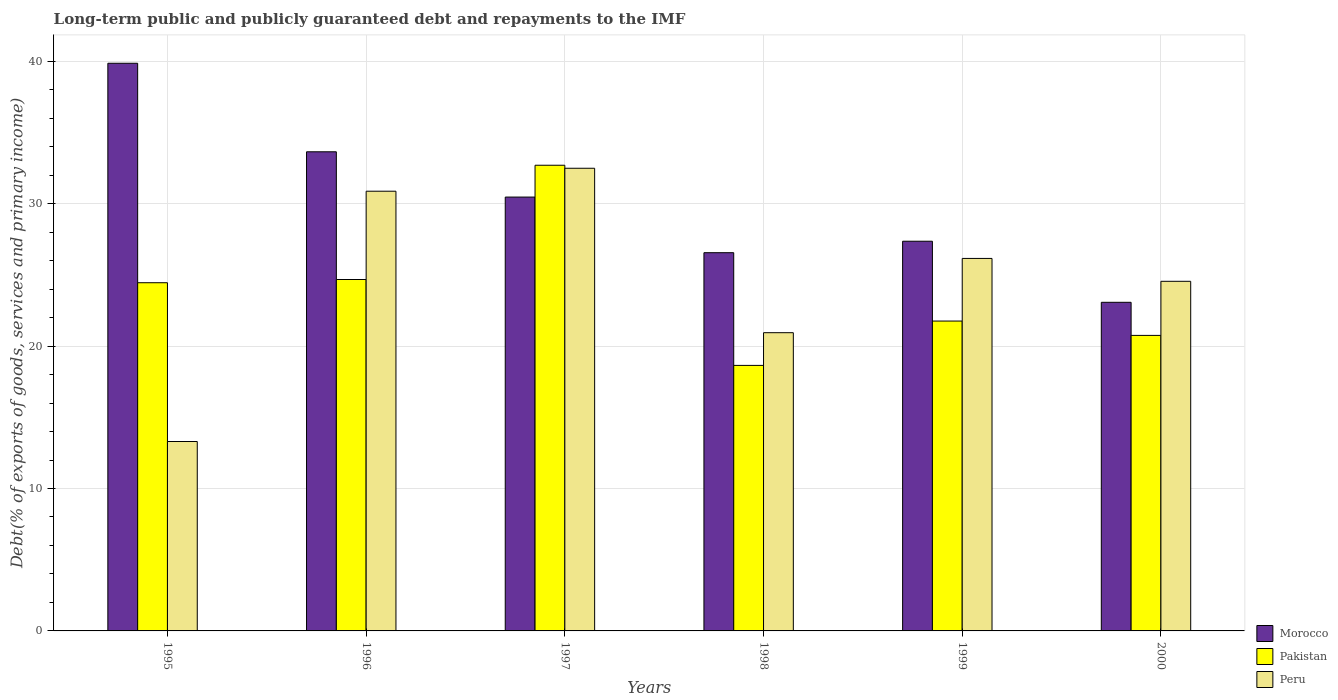How many different coloured bars are there?
Provide a succinct answer. 3. How many groups of bars are there?
Your response must be concise. 6. How many bars are there on the 5th tick from the left?
Make the answer very short. 3. What is the label of the 1st group of bars from the left?
Make the answer very short. 1995. What is the debt and repayments in Peru in 1999?
Your answer should be compact. 26.16. Across all years, what is the maximum debt and repayments in Peru?
Ensure brevity in your answer.  32.49. Across all years, what is the minimum debt and repayments in Morocco?
Make the answer very short. 23.08. What is the total debt and repayments in Peru in the graph?
Keep it short and to the point. 148.31. What is the difference between the debt and repayments in Morocco in 1996 and that in 1997?
Provide a short and direct response. 3.18. What is the difference between the debt and repayments in Peru in 2000 and the debt and repayments in Morocco in 1996?
Provide a short and direct response. -9.09. What is the average debt and repayments in Pakistan per year?
Provide a short and direct response. 23.83. In the year 1999, what is the difference between the debt and repayments in Morocco and debt and repayments in Peru?
Offer a very short reply. 1.21. In how many years, is the debt and repayments in Morocco greater than 36 %?
Give a very brief answer. 1. What is the ratio of the debt and repayments in Morocco in 1995 to that in 2000?
Offer a very short reply. 1.73. Is the difference between the debt and repayments in Morocco in 1995 and 1997 greater than the difference between the debt and repayments in Peru in 1995 and 1997?
Provide a short and direct response. Yes. What is the difference between the highest and the second highest debt and repayments in Morocco?
Provide a succinct answer. 6.22. What is the difference between the highest and the lowest debt and repayments in Peru?
Provide a succinct answer. 19.19. Is the sum of the debt and repayments in Peru in 1997 and 2000 greater than the maximum debt and repayments in Pakistan across all years?
Provide a succinct answer. Yes. What does the 1st bar from the left in 1997 represents?
Your answer should be compact. Morocco. What does the 1st bar from the right in 1996 represents?
Your response must be concise. Peru. Is it the case that in every year, the sum of the debt and repayments in Pakistan and debt and repayments in Morocco is greater than the debt and repayments in Peru?
Keep it short and to the point. Yes. Are all the bars in the graph horizontal?
Your answer should be very brief. No. How many years are there in the graph?
Your answer should be compact. 6. Does the graph contain any zero values?
Offer a very short reply. No. Does the graph contain grids?
Provide a succinct answer. Yes. How many legend labels are there?
Give a very brief answer. 3. How are the legend labels stacked?
Offer a very short reply. Vertical. What is the title of the graph?
Keep it short and to the point. Long-term public and publicly guaranteed debt and repayments to the IMF. What is the label or title of the X-axis?
Your answer should be very brief. Years. What is the label or title of the Y-axis?
Provide a succinct answer. Debt(% of exports of goods, services and primary income). What is the Debt(% of exports of goods, services and primary income) of Morocco in 1995?
Your response must be concise. 39.86. What is the Debt(% of exports of goods, services and primary income) of Pakistan in 1995?
Ensure brevity in your answer.  24.45. What is the Debt(% of exports of goods, services and primary income) in Peru in 1995?
Provide a succinct answer. 13.3. What is the Debt(% of exports of goods, services and primary income) of Morocco in 1996?
Ensure brevity in your answer.  33.64. What is the Debt(% of exports of goods, services and primary income) of Pakistan in 1996?
Offer a terse response. 24.68. What is the Debt(% of exports of goods, services and primary income) in Peru in 1996?
Your response must be concise. 30.88. What is the Debt(% of exports of goods, services and primary income) of Morocco in 1997?
Ensure brevity in your answer.  30.46. What is the Debt(% of exports of goods, services and primary income) of Pakistan in 1997?
Give a very brief answer. 32.7. What is the Debt(% of exports of goods, services and primary income) in Peru in 1997?
Provide a short and direct response. 32.49. What is the Debt(% of exports of goods, services and primary income) in Morocco in 1998?
Your response must be concise. 26.56. What is the Debt(% of exports of goods, services and primary income) in Pakistan in 1998?
Your answer should be compact. 18.64. What is the Debt(% of exports of goods, services and primary income) of Peru in 1998?
Provide a succinct answer. 20.94. What is the Debt(% of exports of goods, services and primary income) in Morocco in 1999?
Offer a terse response. 27.36. What is the Debt(% of exports of goods, services and primary income) of Pakistan in 1999?
Provide a short and direct response. 21.76. What is the Debt(% of exports of goods, services and primary income) in Peru in 1999?
Make the answer very short. 26.16. What is the Debt(% of exports of goods, services and primary income) in Morocco in 2000?
Your response must be concise. 23.08. What is the Debt(% of exports of goods, services and primary income) in Pakistan in 2000?
Keep it short and to the point. 20.75. What is the Debt(% of exports of goods, services and primary income) of Peru in 2000?
Your answer should be very brief. 24.55. Across all years, what is the maximum Debt(% of exports of goods, services and primary income) of Morocco?
Make the answer very short. 39.86. Across all years, what is the maximum Debt(% of exports of goods, services and primary income) of Pakistan?
Offer a very short reply. 32.7. Across all years, what is the maximum Debt(% of exports of goods, services and primary income) in Peru?
Your answer should be compact. 32.49. Across all years, what is the minimum Debt(% of exports of goods, services and primary income) in Morocco?
Your answer should be compact. 23.08. Across all years, what is the minimum Debt(% of exports of goods, services and primary income) in Pakistan?
Ensure brevity in your answer.  18.64. Across all years, what is the minimum Debt(% of exports of goods, services and primary income) in Peru?
Offer a very short reply. 13.3. What is the total Debt(% of exports of goods, services and primary income) of Morocco in the graph?
Your answer should be very brief. 180.97. What is the total Debt(% of exports of goods, services and primary income) in Pakistan in the graph?
Provide a short and direct response. 142.98. What is the total Debt(% of exports of goods, services and primary income) of Peru in the graph?
Your answer should be compact. 148.31. What is the difference between the Debt(% of exports of goods, services and primary income) in Morocco in 1995 and that in 1996?
Make the answer very short. 6.22. What is the difference between the Debt(% of exports of goods, services and primary income) in Pakistan in 1995 and that in 1996?
Your answer should be compact. -0.23. What is the difference between the Debt(% of exports of goods, services and primary income) in Peru in 1995 and that in 1996?
Offer a very short reply. -17.58. What is the difference between the Debt(% of exports of goods, services and primary income) in Morocco in 1995 and that in 1997?
Your response must be concise. 9.4. What is the difference between the Debt(% of exports of goods, services and primary income) in Pakistan in 1995 and that in 1997?
Provide a short and direct response. -8.25. What is the difference between the Debt(% of exports of goods, services and primary income) of Peru in 1995 and that in 1997?
Your answer should be very brief. -19.19. What is the difference between the Debt(% of exports of goods, services and primary income) in Morocco in 1995 and that in 1998?
Provide a succinct answer. 13.3. What is the difference between the Debt(% of exports of goods, services and primary income) of Pakistan in 1995 and that in 1998?
Ensure brevity in your answer.  5.81. What is the difference between the Debt(% of exports of goods, services and primary income) in Peru in 1995 and that in 1998?
Offer a very short reply. -7.64. What is the difference between the Debt(% of exports of goods, services and primary income) of Morocco in 1995 and that in 1999?
Offer a very short reply. 12.5. What is the difference between the Debt(% of exports of goods, services and primary income) of Pakistan in 1995 and that in 1999?
Give a very brief answer. 2.69. What is the difference between the Debt(% of exports of goods, services and primary income) of Peru in 1995 and that in 1999?
Give a very brief answer. -12.86. What is the difference between the Debt(% of exports of goods, services and primary income) in Morocco in 1995 and that in 2000?
Offer a terse response. 16.79. What is the difference between the Debt(% of exports of goods, services and primary income) of Pakistan in 1995 and that in 2000?
Ensure brevity in your answer.  3.7. What is the difference between the Debt(% of exports of goods, services and primary income) of Peru in 1995 and that in 2000?
Provide a succinct answer. -11.25. What is the difference between the Debt(% of exports of goods, services and primary income) in Morocco in 1996 and that in 1997?
Ensure brevity in your answer.  3.18. What is the difference between the Debt(% of exports of goods, services and primary income) of Pakistan in 1996 and that in 1997?
Provide a succinct answer. -8.02. What is the difference between the Debt(% of exports of goods, services and primary income) of Peru in 1996 and that in 1997?
Ensure brevity in your answer.  -1.61. What is the difference between the Debt(% of exports of goods, services and primary income) in Morocco in 1996 and that in 1998?
Offer a very short reply. 7.08. What is the difference between the Debt(% of exports of goods, services and primary income) of Pakistan in 1996 and that in 1998?
Keep it short and to the point. 6.03. What is the difference between the Debt(% of exports of goods, services and primary income) of Peru in 1996 and that in 1998?
Keep it short and to the point. 9.93. What is the difference between the Debt(% of exports of goods, services and primary income) in Morocco in 1996 and that in 1999?
Provide a short and direct response. 6.28. What is the difference between the Debt(% of exports of goods, services and primary income) in Pakistan in 1996 and that in 1999?
Ensure brevity in your answer.  2.92. What is the difference between the Debt(% of exports of goods, services and primary income) of Peru in 1996 and that in 1999?
Offer a terse response. 4.72. What is the difference between the Debt(% of exports of goods, services and primary income) of Morocco in 1996 and that in 2000?
Your response must be concise. 10.57. What is the difference between the Debt(% of exports of goods, services and primary income) of Pakistan in 1996 and that in 2000?
Offer a very short reply. 3.92. What is the difference between the Debt(% of exports of goods, services and primary income) of Peru in 1996 and that in 2000?
Your response must be concise. 6.33. What is the difference between the Debt(% of exports of goods, services and primary income) in Morocco in 1997 and that in 1998?
Offer a terse response. 3.91. What is the difference between the Debt(% of exports of goods, services and primary income) of Pakistan in 1997 and that in 1998?
Provide a short and direct response. 14.05. What is the difference between the Debt(% of exports of goods, services and primary income) in Peru in 1997 and that in 1998?
Your response must be concise. 11.55. What is the difference between the Debt(% of exports of goods, services and primary income) in Morocco in 1997 and that in 1999?
Give a very brief answer. 3.1. What is the difference between the Debt(% of exports of goods, services and primary income) in Pakistan in 1997 and that in 1999?
Offer a very short reply. 10.94. What is the difference between the Debt(% of exports of goods, services and primary income) of Peru in 1997 and that in 1999?
Offer a very short reply. 6.33. What is the difference between the Debt(% of exports of goods, services and primary income) of Morocco in 1997 and that in 2000?
Offer a terse response. 7.39. What is the difference between the Debt(% of exports of goods, services and primary income) of Pakistan in 1997 and that in 2000?
Ensure brevity in your answer.  11.95. What is the difference between the Debt(% of exports of goods, services and primary income) in Peru in 1997 and that in 2000?
Your answer should be compact. 7.94. What is the difference between the Debt(% of exports of goods, services and primary income) of Morocco in 1998 and that in 1999?
Your answer should be very brief. -0.8. What is the difference between the Debt(% of exports of goods, services and primary income) in Pakistan in 1998 and that in 1999?
Your answer should be compact. -3.11. What is the difference between the Debt(% of exports of goods, services and primary income) in Peru in 1998 and that in 1999?
Make the answer very short. -5.21. What is the difference between the Debt(% of exports of goods, services and primary income) of Morocco in 1998 and that in 2000?
Offer a terse response. 3.48. What is the difference between the Debt(% of exports of goods, services and primary income) of Pakistan in 1998 and that in 2000?
Offer a terse response. -2.11. What is the difference between the Debt(% of exports of goods, services and primary income) of Peru in 1998 and that in 2000?
Provide a short and direct response. -3.61. What is the difference between the Debt(% of exports of goods, services and primary income) of Morocco in 1999 and that in 2000?
Make the answer very short. 4.29. What is the difference between the Debt(% of exports of goods, services and primary income) of Pakistan in 1999 and that in 2000?
Your answer should be compact. 1.01. What is the difference between the Debt(% of exports of goods, services and primary income) in Peru in 1999 and that in 2000?
Offer a very short reply. 1.61. What is the difference between the Debt(% of exports of goods, services and primary income) in Morocco in 1995 and the Debt(% of exports of goods, services and primary income) in Pakistan in 1996?
Make the answer very short. 15.18. What is the difference between the Debt(% of exports of goods, services and primary income) of Morocco in 1995 and the Debt(% of exports of goods, services and primary income) of Peru in 1996?
Ensure brevity in your answer.  8.98. What is the difference between the Debt(% of exports of goods, services and primary income) of Pakistan in 1995 and the Debt(% of exports of goods, services and primary income) of Peru in 1996?
Your response must be concise. -6.43. What is the difference between the Debt(% of exports of goods, services and primary income) of Morocco in 1995 and the Debt(% of exports of goods, services and primary income) of Pakistan in 1997?
Your answer should be very brief. 7.16. What is the difference between the Debt(% of exports of goods, services and primary income) in Morocco in 1995 and the Debt(% of exports of goods, services and primary income) in Peru in 1997?
Ensure brevity in your answer.  7.37. What is the difference between the Debt(% of exports of goods, services and primary income) of Pakistan in 1995 and the Debt(% of exports of goods, services and primary income) of Peru in 1997?
Offer a terse response. -8.04. What is the difference between the Debt(% of exports of goods, services and primary income) of Morocco in 1995 and the Debt(% of exports of goods, services and primary income) of Pakistan in 1998?
Offer a very short reply. 21.22. What is the difference between the Debt(% of exports of goods, services and primary income) of Morocco in 1995 and the Debt(% of exports of goods, services and primary income) of Peru in 1998?
Your answer should be compact. 18.92. What is the difference between the Debt(% of exports of goods, services and primary income) in Pakistan in 1995 and the Debt(% of exports of goods, services and primary income) in Peru in 1998?
Make the answer very short. 3.51. What is the difference between the Debt(% of exports of goods, services and primary income) of Morocco in 1995 and the Debt(% of exports of goods, services and primary income) of Pakistan in 1999?
Give a very brief answer. 18.1. What is the difference between the Debt(% of exports of goods, services and primary income) in Morocco in 1995 and the Debt(% of exports of goods, services and primary income) in Peru in 1999?
Keep it short and to the point. 13.7. What is the difference between the Debt(% of exports of goods, services and primary income) of Pakistan in 1995 and the Debt(% of exports of goods, services and primary income) of Peru in 1999?
Provide a succinct answer. -1.71. What is the difference between the Debt(% of exports of goods, services and primary income) in Morocco in 1995 and the Debt(% of exports of goods, services and primary income) in Pakistan in 2000?
Make the answer very short. 19.11. What is the difference between the Debt(% of exports of goods, services and primary income) in Morocco in 1995 and the Debt(% of exports of goods, services and primary income) in Peru in 2000?
Your response must be concise. 15.31. What is the difference between the Debt(% of exports of goods, services and primary income) of Pakistan in 1995 and the Debt(% of exports of goods, services and primary income) of Peru in 2000?
Offer a terse response. -0.1. What is the difference between the Debt(% of exports of goods, services and primary income) of Morocco in 1996 and the Debt(% of exports of goods, services and primary income) of Pakistan in 1997?
Offer a terse response. 0.94. What is the difference between the Debt(% of exports of goods, services and primary income) of Morocco in 1996 and the Debt(% of exports of goods, services and primary income) of Peru in 1997?
Your answer should be very brief. 1.16. What is the difference between the Debt(% of exports of goods, services and primary income) in Pakistan in 1996 and the Debt(% of exports of goods, services and primary income) in Peru in 1997?
Provide a short and direct response. -7.81. What is the difference between the Debt(% of exports of goods, services and primary income) in Morocco in 1996 and the Debt(% of exports of goods, services and primary income) in Pakistan in 1998?
Keep it short and to the point. 15. What is the difference between the Debt(% of exports of goods, services and primary income) in Morocco in 1996 and the Debt(% of exports of goods, services and primary income) in Peru in 1998?
Your answer should be very brief. 12.7. What is the difference between the Debt(% of exports of goods, services and primary income) in Pakistan in 1996 and the Debt(% of exports of goods, services and primary income) in Peru in 1998?
Your response must be concise. 3.73. What is the difference between the Debt(% of exports of goods, services and primary income) of Morocco in 1996 and the Debt(% of exports of goods, services and primary income) of Pakistan in 1999?
Give a very brief answer. 11.89. What is the difference between the Debt(% of exports of goods, services and primary income) of Morocco in 1996 and the Debt(% of exports of goods, services and primary income) of Peru in 1999?
Ensure brevity in your answer.  7.49. What is the difference between the Debt(% of exports of goods, services and primary income) of Pakistan in 1996 and the Debt(% of exports of goods, services and primary income) of Peru in 1999?
Provide a succinct answer. -1.48. What is the difference between the Debt(% of exports of goods, services and primary income) of Morocco in 1996 and the Debt(% of exports of goods, services and primary income) of Pakistan in 2000?
Keep it short and to the point. 12.89. What is the difference between the Debt(% of exports of goods, services and primary income) in Morocco in 1996 and the Debt(% of exports of goods, services and primary income) in Peru in 2000?
Your response must be concise. 9.09. What is the difference between the Debt(% of exports of goods, services and primary income) in Pakistan in 1996 and the Debt(% of exports of goods, services and primary income) in Peru in 2000?
Make the answer very short. 0.13. What is the difference between the Debt(% of exports of goods, services and primary income) in Morocco in 1997 and the Debt(% of exports of goods, services and primary income) in Pakistan in 1998?
Offer a very short reply. 11.82. What is the difference between the Debt(% of exports of goods, services and primary income) in Morocco in 1997 and the Debt(% of exports of goods, services and primary income) in Peru in 1998?
Offer a terse response. 9.52. What is the difference between the Debt(% of exports of goods, services and primary income) of Pakistan in 1997 and the Debt(% of exports of goods, services and primary income) of Peru in 1998?
Provide a succinct answer. 11.76. What is the difference between the Debt(% of exports of goods, services and primary income) of Morocco in 1997 and the Debt(% of exports of goods, services and primary income) of Pakistan in 1999?
Give a very brief answer. 8.71. What is the difference between the Debt(% of exports of goods, services and primary income) of Morocco in 1997 and the Debt(% of exports of goods, services and primary income) of Peru in 1999?
Keep it short and to the point. 4.31. What is the difference between the Debt(% of exports of goods, services and primary income) of Pakistan in 1997 and the Debt(% of exports of goods, services and primary income) of Peru in 1999?
Your answer should be very brief. 6.54. What is the difference between the Debt(% of exports of goods, services and primary income) of Morocco in 1997 and the Debt(% of exports of goods, services and primary income) of Pakistan in 2000?
Make the answer very short. 9.71. What is the difference between the Debt(% of exports of goods, services and primary income) of Morocco in 1997 and the Debt(% of exports of goods, services and primary income) of Peru in 2000?
Your answer should be very brief. 5.91. What is the difference between the Debt(% of exports of goods, services and primary income) of Pakistan in 1997 and the Debt(% of exports of goods, services and primary income) of Peru in 2000?
Make the answer very short. 8.15. What is the difference between the Debt(% of exports of goods, services and primary income) in Morocco in 1998 and the Debt(% of exports of goods, services and primary income) in Pakistan in 1999?
Give a very brief answer. 4.8. What is the difference between the Debt(% of exports of goods, services and primary income) of Morocco in 1998 and the Debt(% of exports of goods, services and primary income) of Peru in 1999?
Provide a succinct answer. 0.4. What is the difference between the Debt(% of exports of goods, services and primary income) of Pakistan in 1998 and the Debt(% of exports of goods, services and primary income) of Peru in 1999?
Ensure brevity in your answer.  -7.51. What is the difference between the Debt(% of exports of goods, services and primary income) of Morocco in 1998 and the Debt(% of exports of goods, services and primary income) of Pakistan in 2000?
Ensure brevity in your answer.  5.81. What is the difference between the Debt(% of exports of goods, services and primary income) of Morocco in 1998 and the Debt(% of exports of goods, services and primary income) of Peru in 2000?
Give a very brief answer. 2.01. What is the difference between the Debt(% of exports of goods, services and primary income) in Pakistan in 1998 and the Debt(% of exports of goods, services and primary income) in Peru in 2000?
Offer a very short reply. -5.91. What is the difference between the Debt(% of exports of goods, services and primary income) of Morocco in 1999 and the Debt(% of exports of goods, services and primary income) of Pakistan in 2000?
Ensure brevity in your answer.  6.61. What is the difference between the Debt(% of exports of goods, services and primary income) in Morocco in 1999 and the Debt(% of exports of goods, services and primary income) in Peru in 2000?
Your answer should be very brief. 2.81. What is the difference between the Debt(% of exports of goods, services and primary income) of Pakistan in 1999 and the Debt(% of exports of goods, services and primary income) of Peru in 2000?
Your answer should be very brief. -2.79. What is the average Debt(% of exports of goods, services and primary income) of Morocco per year?
Offer a very short reply. 30.16. What is the average Debt(% of exports of goods, services and primary income) in Pakistan per year?
Provide a succinct answer. 23.83. What is the average Debt(% of exports of goods, services and primary income) in Peru per year?
Your answer should be very brief. 24.72. In the year 1995, what is the difference between the Debt(% of exports of goods, services and primary income) in Morocco and Debt(% of exports of goods, services and primary income) in Pakistan?
Your answer should be compact. 15.41. In the year 1995, what is the difference between the Debt(% of exports of goods, services and primary income) in Morocco and Debt(% of exports of goods, services and primary income) in Peru?
Provide a succinct answer. 26.56. In the year 1995, what is the difference between the Debt(% of exports of goods, services and primary income) in Pakistan and Debt(% of exports of goods, services and primary income) in Peru?
Your answer should be compact. 11.15. In the year 1996, what is the difference between the Debt(% of exports of goods, services and primary income) in Morocco and Debt(% of exports of goods, services and primary income) in Pakistan?
Your answer should be compact. 8.97. In the year 1996, what is the difference between the Debt(% of exports of goods, services and primary income) of Morocco and Debt(% of exports of goods, services and primary income) of Peru?
Give a very brief answer. 2.77. In the year 1996, what is the difference between the Debt(% of exports of goods, services and primary income) in Pakistan and Debt(% of exports of goods, services and primary income) in Peru?
Your answer should be compact. -6.2. In the year 1997, what is the difference between the Debt(% of exports of goods, services and primary income) of Morocco and Debt(% of exports of goods, services and primary income) of Pakistan?
Offer a very short reply. -2.23. In the year 1997, what is the difference between the Debt(% of exports of goods, services and primary income) in Morocco and Debt(% of exports of goods, services and primary income) in Peru?
Your answer should be compact. -2.02. In the year 1997, what is the difference between the Debt(% of exports of goods, services and primary income) of Pakistan and Debt(% of exports of goods, services and primary income) of Peru?
Your response must be concise. 0.21. In the year 1998, what is the difference between the Debt(% of exports of goods, services and primary income) of Morocco and Debt(% of exports of goods, services and primary income) of Pakistan?
Provide a short and direct response. 7.91. In the year 1998, what is the difference between the Debt(% of exports of goods, services and primary income) of Morocco and Debt(% of exports of goods, services and primary income) of Peru?
Your answer should be very brief. 5.62. In the year 1998, what is the difference between the Debt(% of exports of goods, services and primary income) of Pakistan and Debt(% of exports of goods, services and primary income) of Peru?
Make the answer very short. -2.3. In the year 1999, what is the difference between the Debt(% of exports of goods, services and primary income) of Morocco and Debt(% of exports of goods, services and primary income) of Pakistan?
Your response must be concise. 5.61. In the year 1999, what is the difference between the Debt(% of exports of goods, services and primary income) of Morocco and Debt(% of exports of goods, services and primary income) of Peru?
Your response must be concise. 1.21. In the year 1999, what is the difference between the Debt(% of exports of goods, services and primary income) of Pakistan and Debt(% of exports of goods, services and primary income) of Peru?
Offer a terse response. -4.4. In the year 2000, what is the difference between the Debt(% of exports of goods, services and primary income) of Morocco and Debt(% of exports of goods, services and primary income) of Pakistan?
Ensure brevity in your answer.  2.32. In the year 2000, what is the difference between the Debt(% of exports of goods, services and primary income) in Morocco and Debt(% of exports of goods, services and primary income) in Peru?
Make the answer very short. -1.47. In the year 2000, what is the difference between the Debt(% of exports of goods, services and primary income) in Pakistan and Debt(% of exports of goods, services and primary income) in Peru?
Provide a short and direct response. -3.8. What is the ratio of the Debt(% of exports of goods, services and primary income) of Morocco in 1995 to that in 1996?
Give a very brief answer. 1.18. What is the ratio of the Debt(% of exports of goods, services and primary income) in Pakistan in 1995 to that in 1996?
Your answer should be very brief. 0.99. What is the ratio of the Debt(% of exports of goods, services and primary income) of Peru in 1995 to that in 1996?
Your answer should be very brief. 0.43. What is the ratio of the Debt(% of exports of goods, services and primary income) in Morocco in 1995 to that in 1997?
Offer a very short reply. 1.31. What is the ratio of the Debt(% of exports of goods, services and primary income) in Pakistan in 1995 to that in 1997?
Provide a succinct answer. 0.75. What is the ratio of the Debt(% of exports of goods, services and primary income) of Peru in 1995 to that in 1997?
Offer a very short reply. 0.41. What is the ratio of the Debt(% of exports of goods, services and primary income) in Morocco in 1995 to that in 1998?
Your response must be concise. 1.5. What is the ratio of the Debt(% of exports of goods, services and primary income) of Pakistan in 1995 to that in 1998?
Make the answer very short. 1.31. What is the ratio of the Debt(% of exports of goods, services and primary income) of Peru in 1995 to that in 1998?
Offer a terse response. 0.64. What is the ratio of the Debt(% of exports of goods, services and primary income) of Morocco in 1995 to that in 1999?
Ensure brevity in your answer.  1.46. What is the ratio of the Debt(% of exports of goods, services and primary income) in Pakistan in 1995 to that in 1999?
Offer a very short reply. 1.12. What is the ratio of the Debt(% of exports of goods, services and primary income) of Peru in 1995 to that in 1999?
Offer a very short reply. 0.51. What is the ratio of the Debt(% of exports of goods, services and primary income) of Morocco in 1995 to that in 2000?
Offer a terse response. 1.73. What is the ratio of the Debt(% of exports of goods, services and primary income) in Pakistan in 1995 to that in 2000?
Your answer should be compact. 1.18. What is the ratio of the Debt(% of exports of goods, services and primary income) of Peru in 1995 to that in 2000?
Ensure brevity in your answer.  0.54. What is the ratio of the Debt(% of exports of goods, services and primary income) in Morocco in 1996 to that in 1997?
Your answer should be very brief. 1.1. What is the ratio of the Debt(% of exports of goods, services and primary income) in Pakistan in 1996 to that in 1997?
Provide a short and direct response. 0.75. What is the ratio of the Debt(% of exports of goods, services and primary income) in Peru in 1996 to that in 1997?
Ensure brevity in your answer.  0.95. What is the ratio of the Debt(% of exports of goods, services and primary income) of Morocco in 1996 to that in 1998?
Keep it short and to the point. 1.27. What is the ratio of the Debt(% of exports of goods, services and primary income) in Pakistan in 1996 to that in 1998?
Your answer should be very brief. 1.32. What is the ratio of the Debt(% of exports of goods, services and primary income) of Peru in 1996 to that in 1998?
Make the answer very short. 1.47. What is the ratio of the Debt(% of exports of goods, services and primary income) in Morocco in 1996 to that in 1999?
Make the answer very short. 1.23. What is the ratio of the Debt(% of exports of goods, services and primary income) of Pakistan in 1996 to that in 1999?
Your response must be concise. 1.13. What is the ratio of the Debt(% of exports of goods, services and primary income) in Peru in 1996 to that in 1999?
Give a very brief answer. 1.18. What is the ratio of the Debt(% of exports of goods, services and primary income) in Morocco in 1996 to that in 2000?
Your answer should be compact. 1.46. What is the ratio of the Debt(% of exports of goods, services and primary income) in Pakistan in 1996 to that in 2000?
Provide a succinct answer. 1.19. What is the ratio of the Debt(% of exports of goods, services and primary income) of Peru in 1996 to that in 2000?
Offer a terse response. 1.26. What is the ratio of the Debt(% of exports of goods, services and primary income) in Morocco in 1997 to that in 1998?
Offer a terse response. 1.15. What is the ratio of the Debt(% of exports of goods, services and primary income) in Pakistan in 1997 to that in 1998?
Offer a terse response. 1.75. What is the ratio of the Debt(% of exports of goods, services and primary income) of Peru in 1997 to that in 1998?
Provide a short and direct response. 1.55. What is the ratio of the Debt(% of exports of goods, services and primary income) of Morocco in 1997 to that in 1999?
Give a very brief answer. 1.11. What is the ratio of the Debt(% of exports of goods, services and primary income) in Pakistan in 1997 to that in 1999?
Keep it short and to the point. 1.5. What is the ratio of the Debt(% of exports of goods, services and primary income) of Peru in 1997 to that in 1999?
Offer a terse response. 1.24. What is the ratio of the Debt(% of exports of goods, services and primary income) in Morocco in 1997 to that in 2000?
Your answer should be compact. 1.32. What is the ratio of the Debt(% of exports of goods, services and primary income) in Pakistan in 1997 to that in 2000?
Your answer should be compact. 1.58. What is the ratio of the Debt(% of exports of goods, services and primary income) in Peru in 1997 to that in 2000?
Keep it short and to the point. 1.32. What is the ratio of the Debt(% of exports of goods, services and primary income) of Morocco in 1998 to that in 1999?
Your response must be concise. 0.97. What is the ratio of the Debt(% of exports of goods, services and primary income) in Pakistan in 1998 to that in 1999?
Your response must be concise. 0.86. What is the ratio of the Debt(% of exports of goods, services and primary income) in Peru in 1998 to that in 1999?
Your answer should be very brief. 0.8. What is the ratio of the Debt(% of exports of goods, services and primary income) in Morocco in 1998 to that in 2000?
Your answer should be very brief. 1.15. What is the ratio of the Debt(% of exports of goods, services and primary income) of Pakistan in 1998 to that in 2000?
Offer a terse response. 0.9. What is the ratio of the Debt(% of exports of goods, services and primary income) in Peru in 1998 to that in 2000?
Give a very brief answer. 0.85. What is the ratio of the Debt(% of exports of goods, services and primary income) in Morocco in 1999 to that in 2000?
Make the answer very short. 1.19. What is the ratio of the Debt(% of exports of goods, services and primary income) in Pakistan in 1999 to that in 2000?
Keep it short and to the point. 1.05. What is the ratio of the Debt(% of exports of goods, services and primary income) in Peru in 1999 to that in 2000?
Your response must be concise. 1.07. What is the difference between the highest and the second highest Debt(% of exports of goods, services and primary income) of Morocco?
Your response must be concise. 6.22. What is the difference between the highest and the second highest Debt(% of exports of goods, services and primary income) in Pakistan?
Offer a terse response. 8.02. What is the difference between the highest and the second highest Debt(% of exports of goods, services and primary income) in Peru?
Offer a very short reply. 1.61. What is the difference between the highest and the lowest Debt(% of exports of goods, services and primary income) of Morocco?
Offer a very short reply. 16.79. What is the difference between the highest and the lowest Debt(% of exports of goods, services and primary income) in Pakistan?
Provide a short and direct response. 14.05. What is the difference between the highest and the lowest Debt(% of exports of goods, services and primary income) in Peru?
Keep it short and to the point. 19.19. 